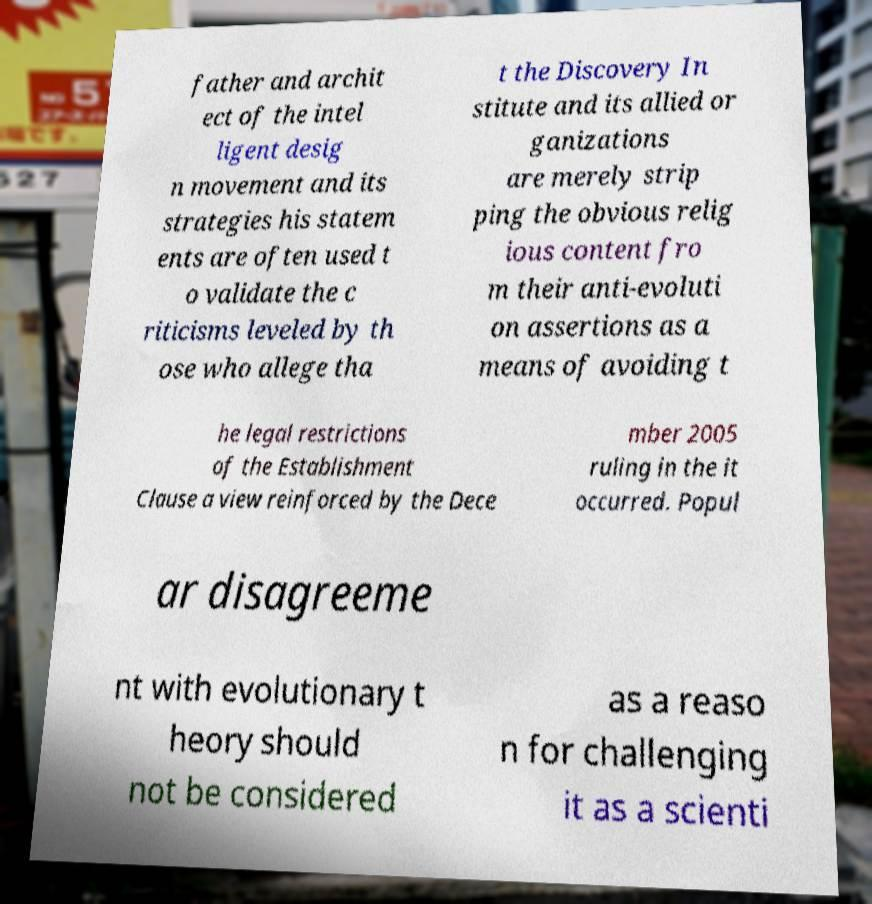Please read and relay the text visible in this image. What does it say? father and archit ect of the intel ligent desig n movement and its strategies his statem ents are often used t o validate the c riticisms leveled by th ose who allege tha t the Discovery In stitute and its allied or ganizations are merely strip ping the obvious relig ious content fro m their anti-evoluti on assertions as a means of avoiding t he legal restrictions of the Establishment Clause a view reinforced by the Dece mber 2005 ruling in the it occurred. Popul ar disagreeme nt with evolutionary t heory should not be considered as a reaso n for challenging it as a scienti 